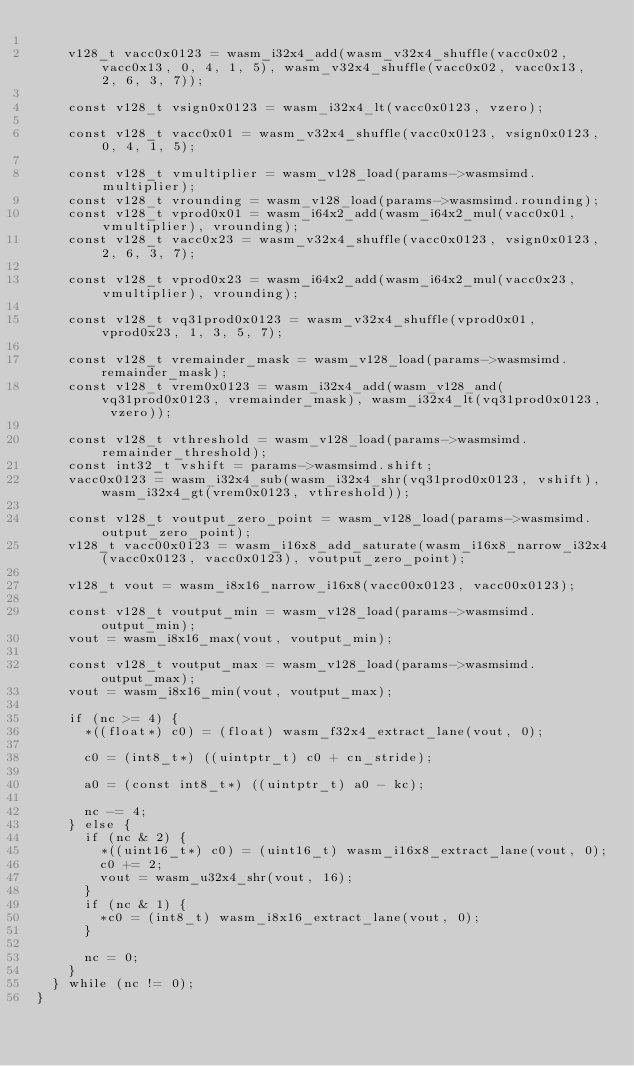<code> <loc_0><loc_0><loc_500><loc_500><_C_>
    v128_t vacc0x0123 = wasm_i32x4_add(wasm_v32x4_shuffle(vacc0x02, vacc0x13, 0, 4, 1, 5), wasm_v32x4_shuffle(vacc0x02, vacc0x13, 2, 6, 3, 7));

    const v128_t vsign0x0123 = wasm_i32x4_lt(vacc0x0123, vzero);

    const v128_t vacc0x01 = wasm_v32x4_shuffle(vacc0x0123, vsign0x0123, 0, 4, 1, 5);

    const v128_t vmultiplier = wasm_v128_load(params->wasmsimd.multiplier);
    const v128_t vrounding = wasm_v128_load(params->wasmsimd.rounding);
    const v128_t vprod0x01 = wasm_i64x2_add(wasm_i64x2_mul(vacc0x01, vmultiplier), vrounding);
    const v128_t vacc0x23 = wasm_v32x4_shuffle(vacc0x0123, vsign0x0123, 2, 6, 3, 7);

    const v128_t vprod0x23 = wasm_i64x2_add(wasm_i64x2_mul(vacc0x23, vmultiplier), vrounding);

    const v128_t vq31prod0x0123 = wasm_v32x4_shuffle(vprod0x01, vprod0x23, 1, 3, 5, 7);

    const v128_t vremainder_mask = wasm_v128_load(params->wasmsimd.remainder_mask);
    const v128_t vrem0x0123 = wasm_i32x4_add(wasm_v128_and(vq31prod0x0123, vremainder_mask), wasm_i32x4_lt(vq31prod0x0123, vzero));

    const v128_t vthreshold = wasm_v128_load(params->wasmsimd.remainder_threshold);
    const int32_t vshift = params->wasmsimd.shift;
    vacc0x0123 = wasm_i32x4_sub(wasm_i32x4_shr(vq31prod0x0123, vshift), wasm_i32x4_gt(vrem0x0123, vthreshold));

    const v128_t voutput_zero_point = wasm_v128_load(params->wasmsimd.output_zero_point);
    v128_t vacc00x0123 = wasm_i16x8_add_saturate(wasm_i16x8_narrow_i32x4(vacc0x0123, vacc0x0123), voutput_zero_point);

    v128_t vout = wasm_i8x16_narrow_i16x8(vacc00x0123, vacc00x0123);

    const v128_t voutput_min = wasm_v128_load(params->wasmsimd.output_min);
    vout = wasm_i8x16_max(vout, voutput_min);

    const v128_t voutput_max = wasm_v128_load(params->wasmsimd.output_max);
    vout = wasm_i8x16_min(vout, voutput_max);

    if (nc >= 4) {
      *((float*) c0) = (float) wasm_f32x4_extract_lane(vout, 0);

      c0 = (int8_t*) ((uintptr_t) c0 + cn_stride);

      a0 = (const int8_t*) ((uintptr_t) a0 - kc);

      nc -= 4;
    } else {
      if (nc & 2) {
        *((uint16_t*) c0) = (uint16_t) wasm_i16x8_extract_lane(vout, 0);
        c0 += 2;
        vout = wasm_u32x4_shr(vout, 16);
      }
      if (nc & 1) {
        *c0 = (int8_t) wasm_i8x16_extract_lane(vout, 0);
      }

      nc = 0;
    }
  } while (nc != 0);
}
</code> 